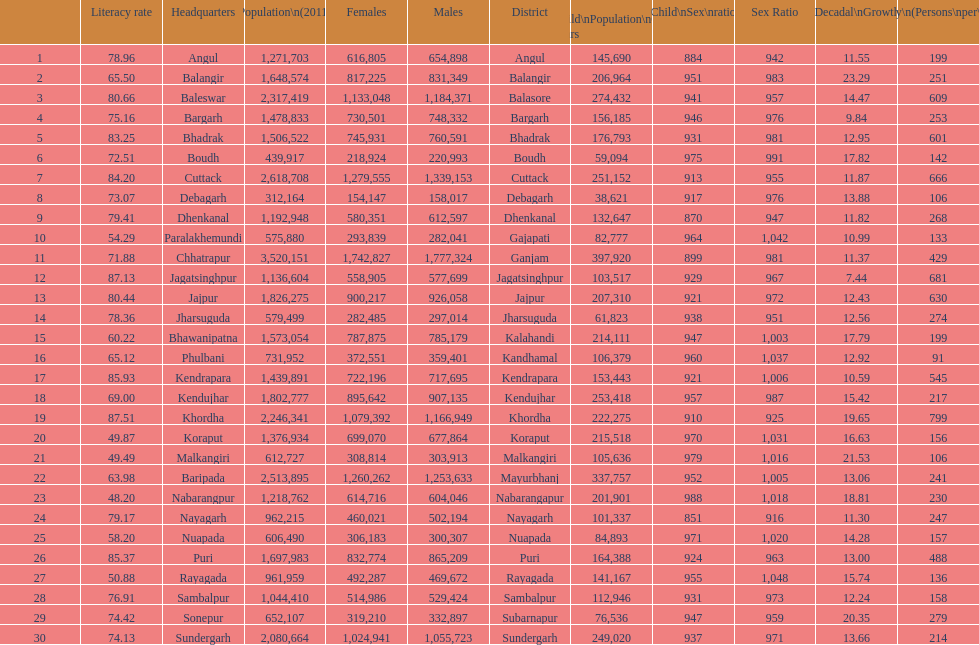How many females live in cuttack? 1,279,555. 